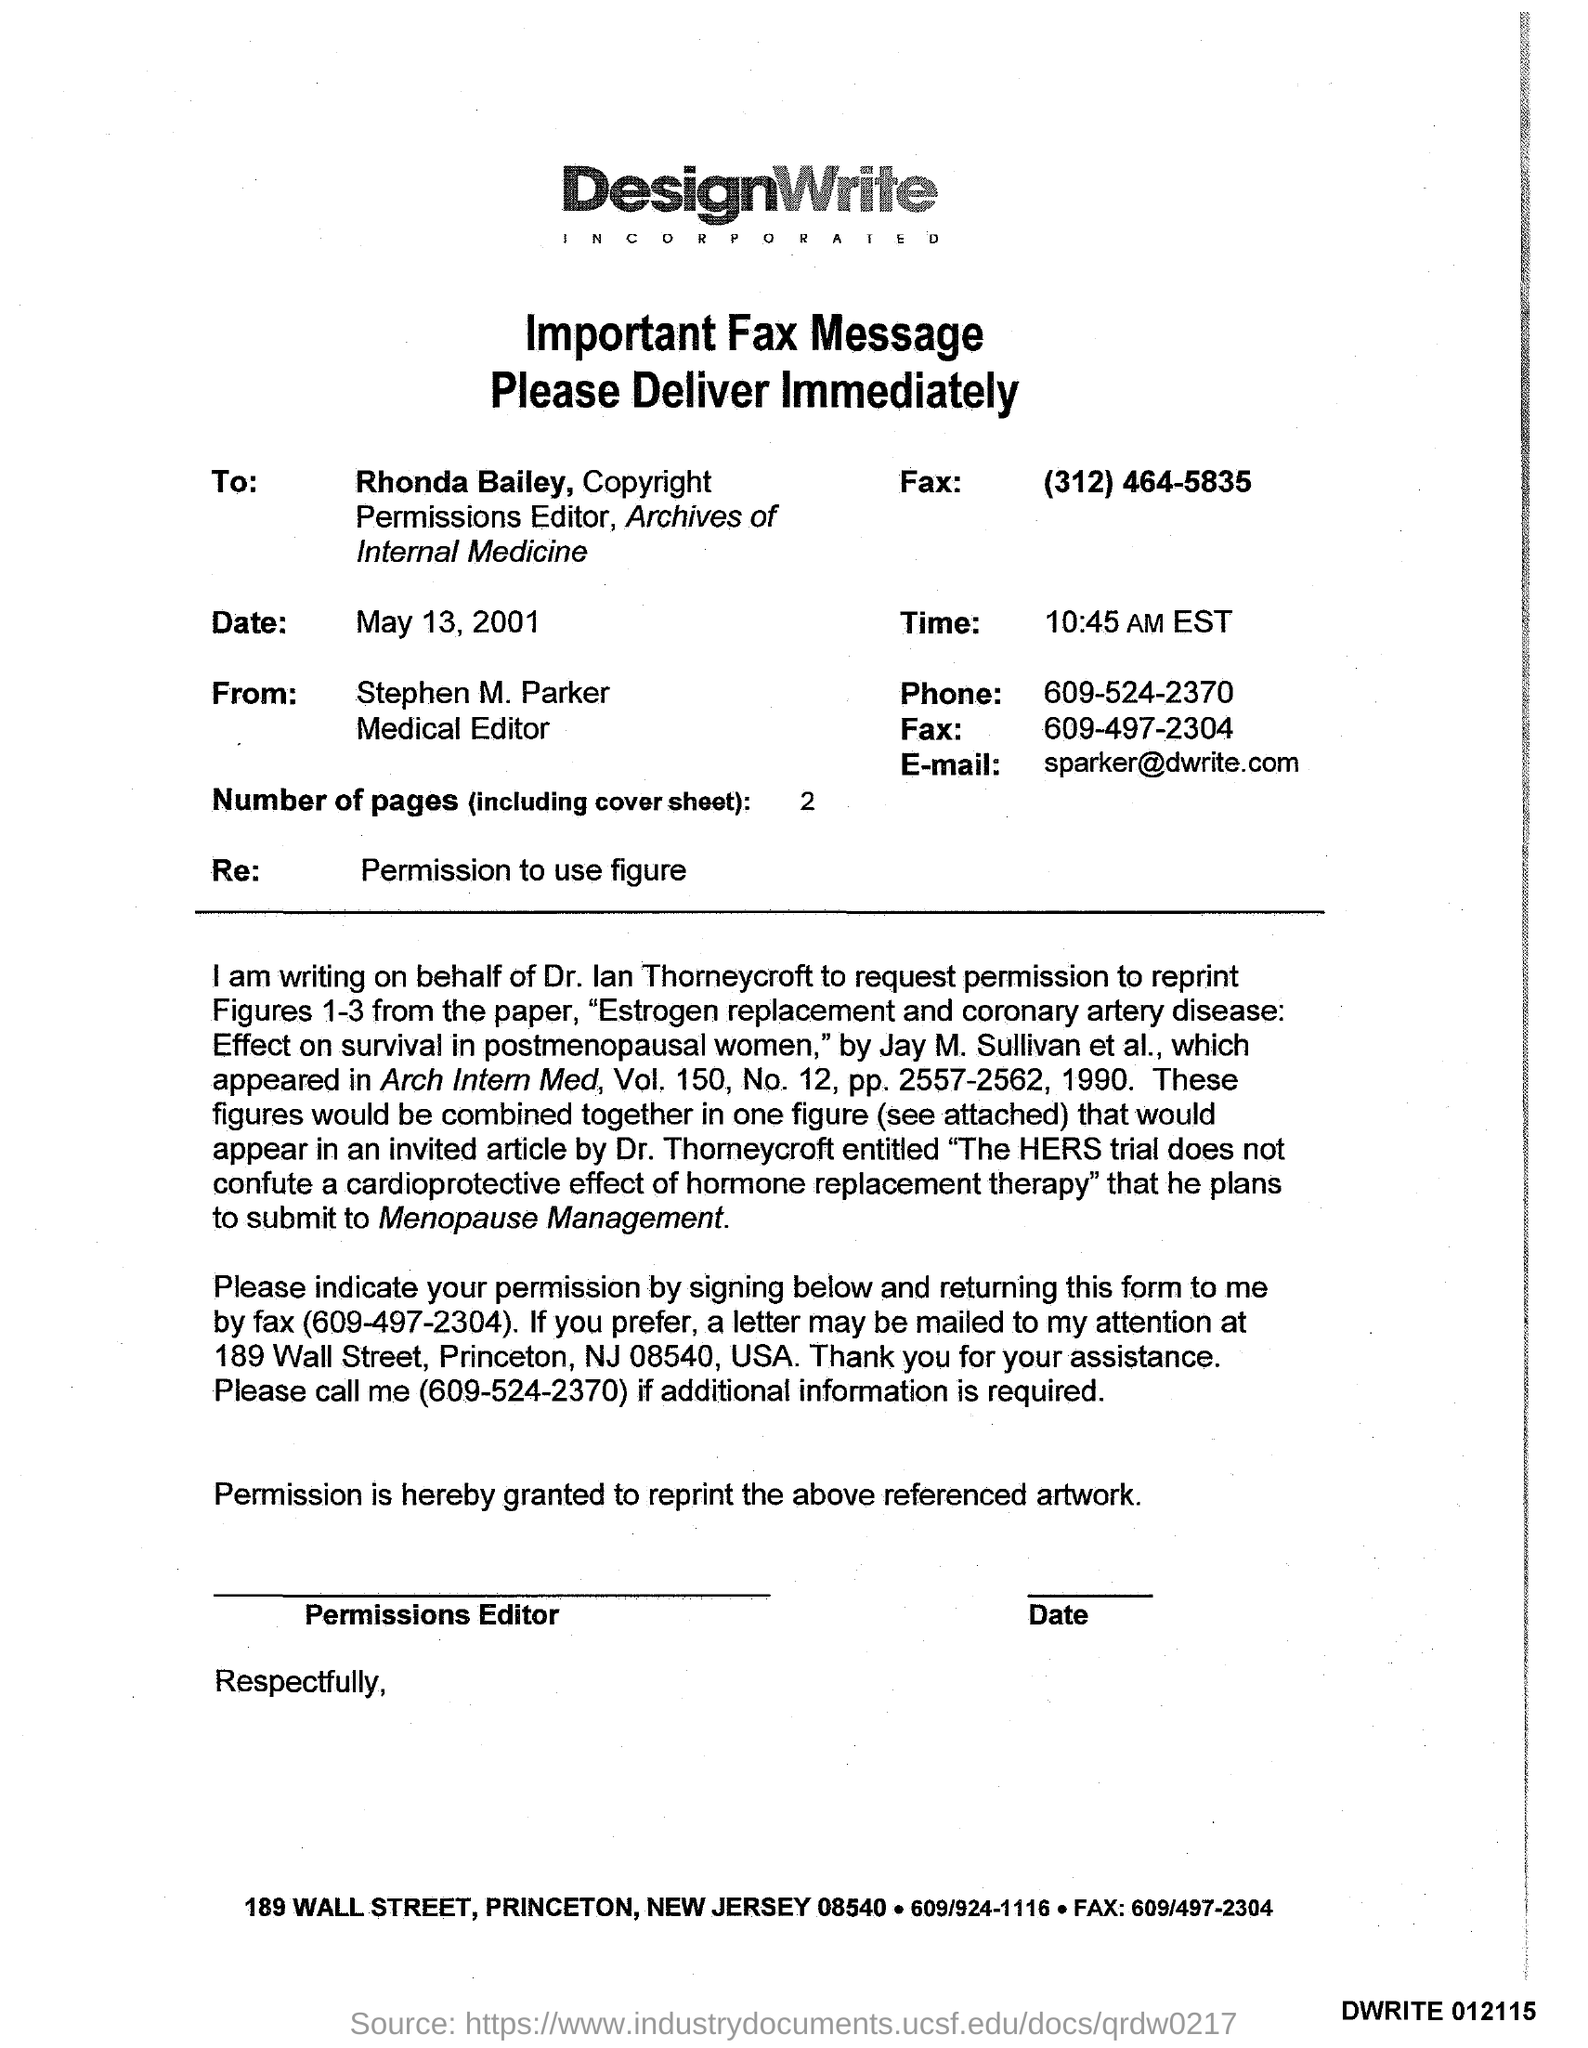Who is the sender of the Fax?
Provide a short and direct response. Stephen M. Parker. What is the designation of Stephen M. Parker?
Your answer should be compact. Medical Editor. What is the Phone No of Stephen M. Parker?
Your response must be concise. 609-524-2370. Who is the receiver of the Fax?
Your response must be concise. Rhonda Bailey. What is the fax no of Rhonda Bailey?
Provide a short and direct response. (312) 464-5835. What is the Email id of Stephen M. Parker?
Give a very brief answer. Sparker@dwrite.com. What is the date mentioned in the fax?
Your answer should be very brief. May 13, 2001. What is the time mentioned in the fax?
Offer a terse response. 10:45 AM EST. How many pages are there in the fax including cover sheet?
Ensure brevity in your answer.  2. 